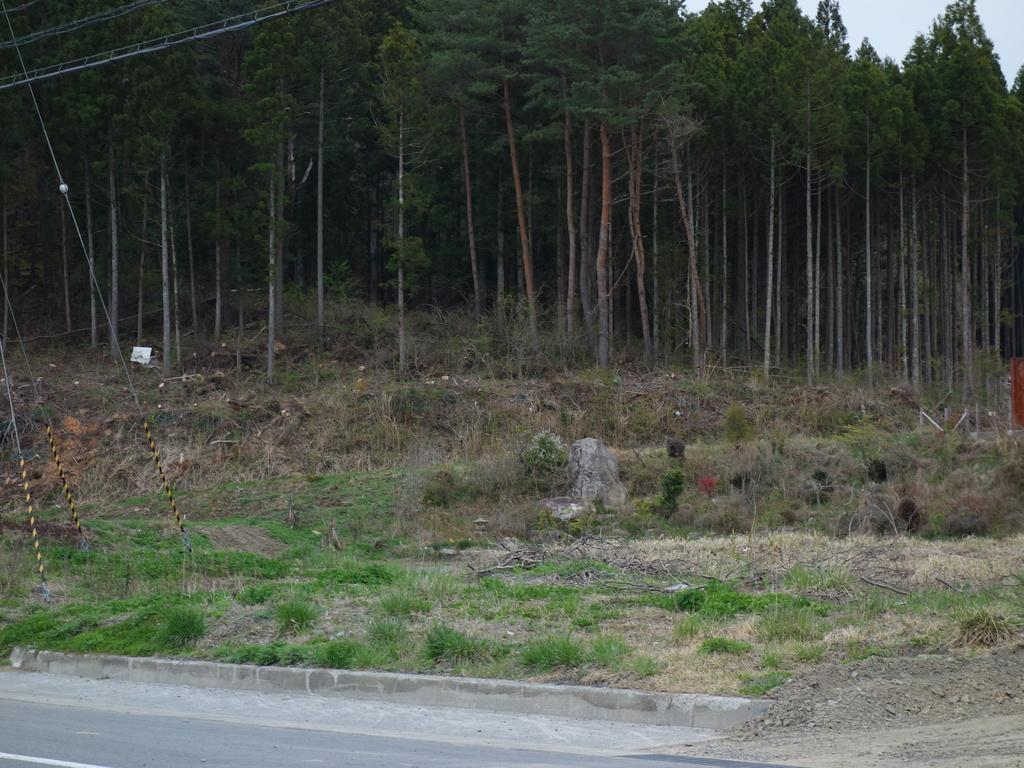What type of vegetation is present in the image? There is grass in the image. What color is the grass in the image? The grass is green. What other natural elements can be seen in the image? There are trees in the image. What color are the trees in the image? The trees are green. What can be seen in the background of the image? The sky is visible in the background of the image. What color is the sky in the image? The sky is white. What type of hospital can be seen in the image? There is no hospital present in the image; it features grass, trees, and a white sky. How many dimes are scattered on the grass in the image? There are no dimes present in the image; it only features grass, trees, and a white sky. 